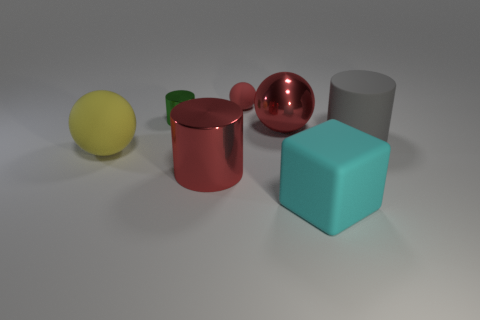Does the big yellow thing have the same material as the big red cylinder?
Give a very brief answer. No. What size is the metal cylinder in front of the matte object to the left of the tiny cylinder?
Offer a terse response. Large. What number of red rubber objects have the same shape as the gray matte thing?
Your answer should be very brief. 0. Is the block the same color as the metallic sphere?
Your answer should be compact. No. Is there anything else that is the same shape as the gray thing?
Your answer should be compact. Yes. Are there any big matte cubes of the same color as the small metallic cylinder?
Your response must be concise. No. Are the big cylinder on the right side of the big block and the large red object behind the big gray object made of the same material?
Make the answer very short. No. The small cylinder has what color?
Your answer should be very brief. Green. How big is the matte object that is behind the big red object behind the rubber ball in front of the gray object?
Ensure brevity in your answer.  Small. What number of other things are the same size as the red cylinder?
Give a very brief answer. 4. 